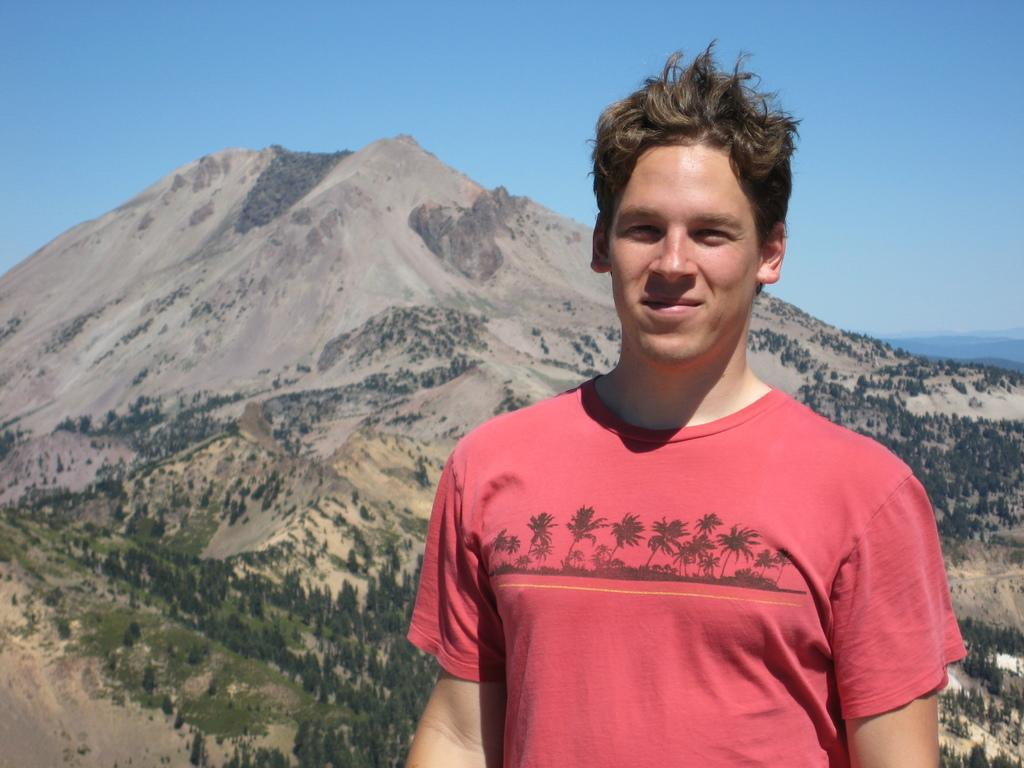Who is present in the image? There is a man in the image. What can be seen in the background of the image? There is a mountain, trees, and the sky visible in the background of the image. How many dogs are present in the image? There are no dogs present in the image. What type of square can be seen in the image? There is no square present in the image. 